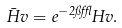<formula> <loc_0><loc_0><loc_500><loc_500>\bar { H } v = e ^ { - 2 \pi \epsilon } H v .</formula> 